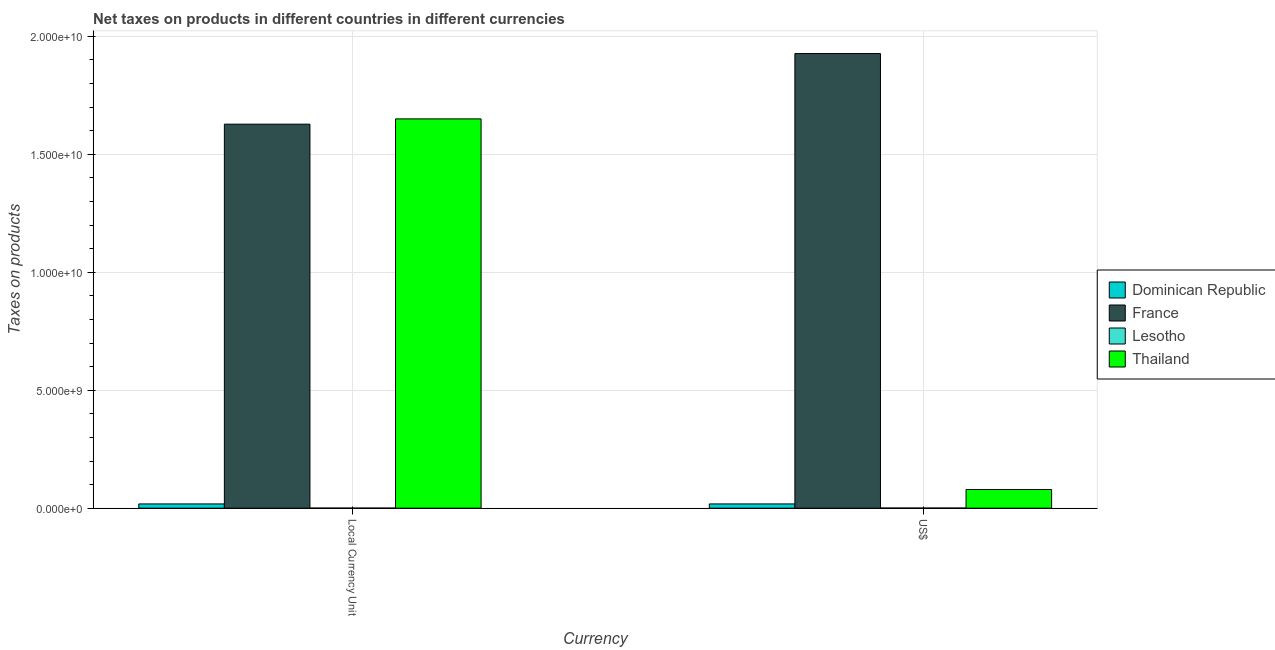Are the number of bars on each tick of the X-axis equal?
Make the answer very short. Yes. How many bars are there on the 2nd tick from the left?
Give a very brief answer. 4. How many bars are there on the 2nd tick from the right?
Make the answer very short. 4. What is the label of the 2nd group of bars from the left?
Provide a succinct answer. US$. What is the net taxes in constant 2005 us$ in Thailand?
Offer a very short reply. 1.65e+1. Across all countries, what is the maximum net taxes in us$?
Your answer should be very brief. 1.93e+1. Across all countries, what is the minimum net taxes in constant 2005 us$?
Make the answer very short. 4.40e+06. In which country was the net taxes in constant 2005 us$ maximum?
Your answer should be very brief. Thailand. In which country was the net taxes in constant 2005 us$ minimum?
Your response must be concise. Lesotho. What is the total net taxes in us$ in the graph?
Your answer should be compact. 2.02e+1. What is the difference between the net taxes in us$ in France and that in Lesotho?
Your answer should be compact. 1.93e+1. What is the difference between the net taxes in constant 2005 us$ in Dominican Republic and the net taxes in us$ in Lesotho?
Your answer should be compact. 1.74e+08. What is the average net taxes in constant 2005 us$ per country?
Offer a terse response. 8.24e+09. What is the difference between the net taxes in constant 2005 us$ and net taxes in us$ in France?
Offer a very short reply. -2.99e+09. What is the ratio of the net taxes in constant 2005 us$ in Dominican Republic to that in France?
Keep it short and to the point. 0.01. In how many countries, is the net taxes in us$ greater than the average net taxes in us$ taken over all countries?
Your response must be concise. 1. What does the 4th bar from the left in US$ represents?
Provide a succinct answer. Thailand. What does the 1st bar from the right in US$ represents?
Offer a terse response. Thailand. What is the difference between two consecutive major ticks on the Y-axis?
Give a very brief answer. 5.00e+09. Are the values on the major ticks of Y-axis written in scientific E-notation?
Your answer should be compact. Yes. Does the graph contain any zero values?
Your answer should be very brief. No. Where does the legend appear in the graph?
Keep it short and to the point. Center right. How are the legend labels stacked?
Offer a very short reply. Vertical. What is the title of the graph?
Ensure brevity in your answer.  Net taxes on products in different countries in different currencies. What is the label or title of the X-axis?
Provide a short and direct response. Currency. What is the label or title of the Y-axis?
Offer a very short reply. Taxes on products. What is the Taxes on products of Dominican Republic in Local Currency Unit?
Provide a short and direct response. 1.80e+08. What is the Taxes on products of France in Local Currency Unit?
Offer a very short reply. 1.63e+1. What is the Taxes on products of Lesotho in Local Currency Unit?
Give a very brief answer. 4.40e+06. What is the Taxes on products in Thailand in Local Currency Unit?
Give a very brief answer. 1.65e+1. What is the Taxes on products in Dominican Republic in US$?
Give a very brief answer. 1.80e+08. What is the Taxes on products of France in US$?
Give a very brief answer. 1.93e+1. What is the Taxes on products of Lesotho in US$?
Give a very brief answer. 6.15e+06. What is the Taxes on products of Thailand in US$?
Provide a short and direct response. 7.93e+08. Across all Currency, what is the maximum Taxes on products of Dominican Republic?
Make the answer very short. 1.80e+08. Across all Currency, what is the maximum Taxes on products in France?
Keep it short and to the point. 1.93e+1. Across all Currency, what is the maximum Taxes on products in Lesotho?
Your response must be concise. 6.15e+06. Across all Currency, what is the maximum Taxes on products of Thailand?
Provide a short and direct response. 1.65e+1. Across all Currency, what is the minimum Taxes on products of Dominican Republic?
Provide a short and direct response. 1.80e+08. Across all Currency, what is the minimum Taxes on products in France?
Offer a terse response. 1.63e+1. Across all Currency, what is the minimum Taxes on products of Lesotho?
Provide a succinct answer. 4.40e+06. Across all Currency, what is the minimum Taxes on products of Thailand?
Provide a short and direct response. 7.93e+08. What is the total Taxes on products of Dominican Republic in the graph?
Provide a succinct answer. 3.61e+08. What is the total Taxes on products in France in the graph?
Keep it short and to the point. 3.55e+1. What is the total Taxes on products of Lesotho in the graph?
Offer a terse response. 1.06e+07. What is the total Taxes on products in Thailand in the graph?
Provide a short and direct response. 1.73e+1. What is the difference between the Taxes on products of France in Local Currency Unit and that in US$?
Provide a succinct answer. -2.99e+09. What is the difference between the Taxes on products in Lesotho in Local Currency Unit and that in US$?
Give a very brief answer. -1.75e+06. What is the difference between the Taxes on products of Thailand in Local Currency Unit and that in US$?
Ensure brevity in your answer.  1.57e+1. What is the difference between the Taxes on products of Dominican Republic in Local Currency Unit and the Taxes on products of France in US$?
Your answer should be compact. -1.91e+1. What is the difference between the Taxes on products in Dominican Republic in Local Currency Unit and the Taxes on products in Lesotho in US$?
Provide a short and direct response. 1.74e+08. What is the difference between the Taxes on products of Dominican Republic in Local Currency Unit and the Taxes on products of Thailand in US$?
Offer a very short reply. -6.13e+08. What is the difference between the Taxes on products in France in Local Currency Unit and the Taxes on products in Lesotho in US$?
Make the answer very short. 1.63e+1. What is the difference between the Taxes on products of France in Local Currency Unit and the Taxes on products of Thailand in US$?
Your response must be concise. 1.55e+1. What is the difference between the Taxes on products of Lesotho in Local Currency Unit and the Taxes on products of Thailand in US$?
Offer a very short reply. -7.89e+08. What is the average Taxes on products of Dominican Republic per Currency?
Give a very brief answer. 1.80e+08. What is the average Taxes on products in France per Currency?
Your answer should be compact. 1.78e+1. What is the average Taxes on products of Lesotho per Currency?
Provide a succinct answer. 5.28e+06. What is the average Taxes on products of Thailand per Currency?
Your answer should be very brief. 8.65e+09. What is the difference between the Taxes on products in Dominican Republic and Taxes on products in France in Local Currency Unit?
Give a very brief answer. -1.61e+1. What is the difference between the Taxes on products of Dominican Republic and Taxes on products of Lesotho in Local Currency Unit?
Ensure brevity in your answer.  1.76e+08. What is the difference between the Taxes on products in Dominican Republic and Taxes on products in Thailand in Local Currency Unit?
Your response must be concise. -1.63e+1. What is the difference between the Taxes on products of France and Taxes on products of Lesotho in Local Currency Unit?
Offer a terse response. 1.63e+1. What is the difference between the Taxes on products of France and Taxes on products of Thailand in Local Currency Unit?
Keep it short and to the point. -2.24e+08. What is the difference between the Taxes on products of Lesotho and Taxes on products of Thailand in Local Currency Unit?
Your answer should be very brief. -1.65e+1. What is the difference between the Taxes on products in Dominican Republic and Taxes on products in France in US$?
Ensure brevity in your answer.  -1.91e+1. What is the difference between the Taxes on products of Dominican Republic and Taxes on products of Lesotho in US$?
Offer a very short reply. 1.74e+08. What is the difference between the Taxes on products in Dominican Republic and Taxes on products in Thailand in US$?
Keep it short and to the point. -6.13e+08. What is the difference between the Taxes on products of France and Taxes on products of Lesotho in US$?
Your answer should be compact. 1.93e+1. What is the difference between the Taxes on products in France and Taxes on products in Thailand in US$?
Offer a terse response. 1.85e+1. What is the difference between the Taxes on products in Lesotho and Taxes on products in Thailand in US$?
Provide a succinct answer. -7.87e+08. What is the ratio of the Taxes on products of Dominican Republic in Local Currency Unit to that in US$?
Your answer should be compact. 1. What is the ratio of the Taxes on products of France in Local Currency Unit to that in US$?
Your answer should be compact. 0.84. What is the ratio of the Taxes on products in Lesotho in Local Currency Unit to that in US$?
Make the answer very short. 0.72. What is the ratio of the Taxes on products of Thailand in Local Currency Unit to that in US$?
Ensure brevity in your answer.  20.8. What is the difference between the highest and the second highest Taxes on products of Dominican Republic?
Ensure brevity in your answer.  0. What is the difference between the highest and the second highest Taxes on products in France?
Ensure brevity in your answer.  2.99e+09. What is the difference between the highest and the second highest Taxes on products in Lesotho?
Provide a succinct answer. 1.75e+06. What is the difference between the highest and the second highest Taxes on products in Thailand?
Keep it short and to the point. 1.57e+1. What is the difference between the highest and the lowest Taxes on products in France?
Make the answer very short. 2.99e+09. What is the difference between the highest and the lowest Taxes on products in Lesotho?
Provide a succinct answer. 1.75e+06. What is the difference between the highest and the lowest Taxes on products of Thailand?
Give a very brief answer. 1.57e+1. 